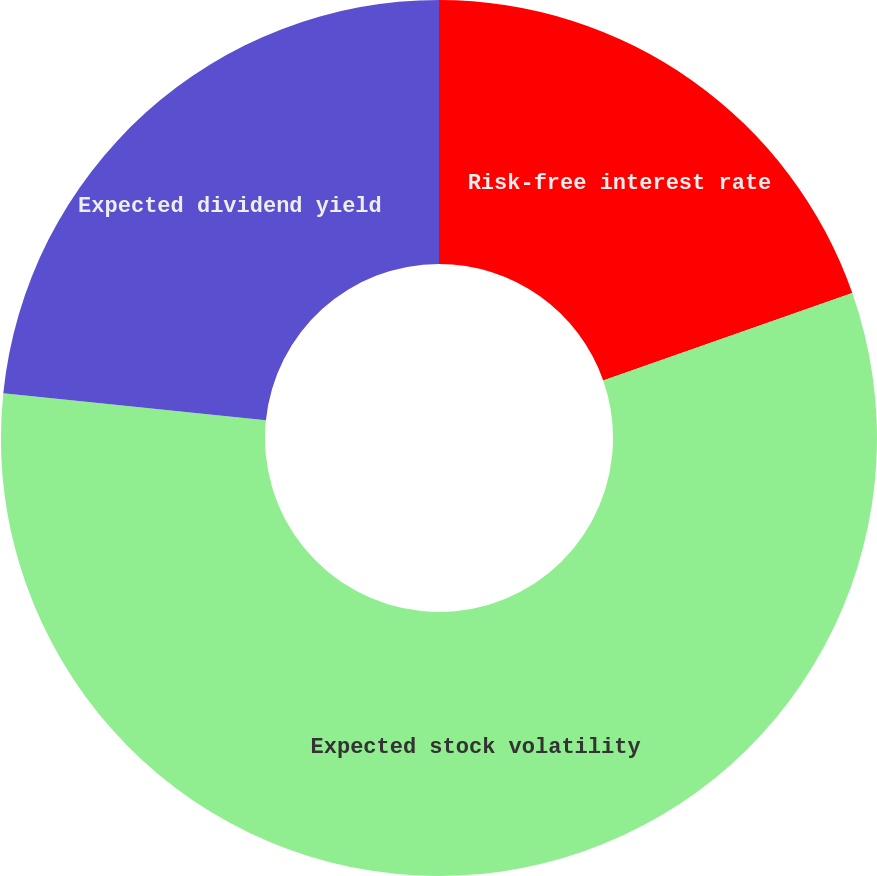Convert chart to OTSL. <chart><loc_0><loc_0><loc_500><loc_500><pie_chart><fcel>Risk-free interest rate<fcel>Expected stock volatility<fcel>Expected dividend yield<nl><fcel>19.63%<fcel>56.99%<fcel>23.37%<nl></chart> 